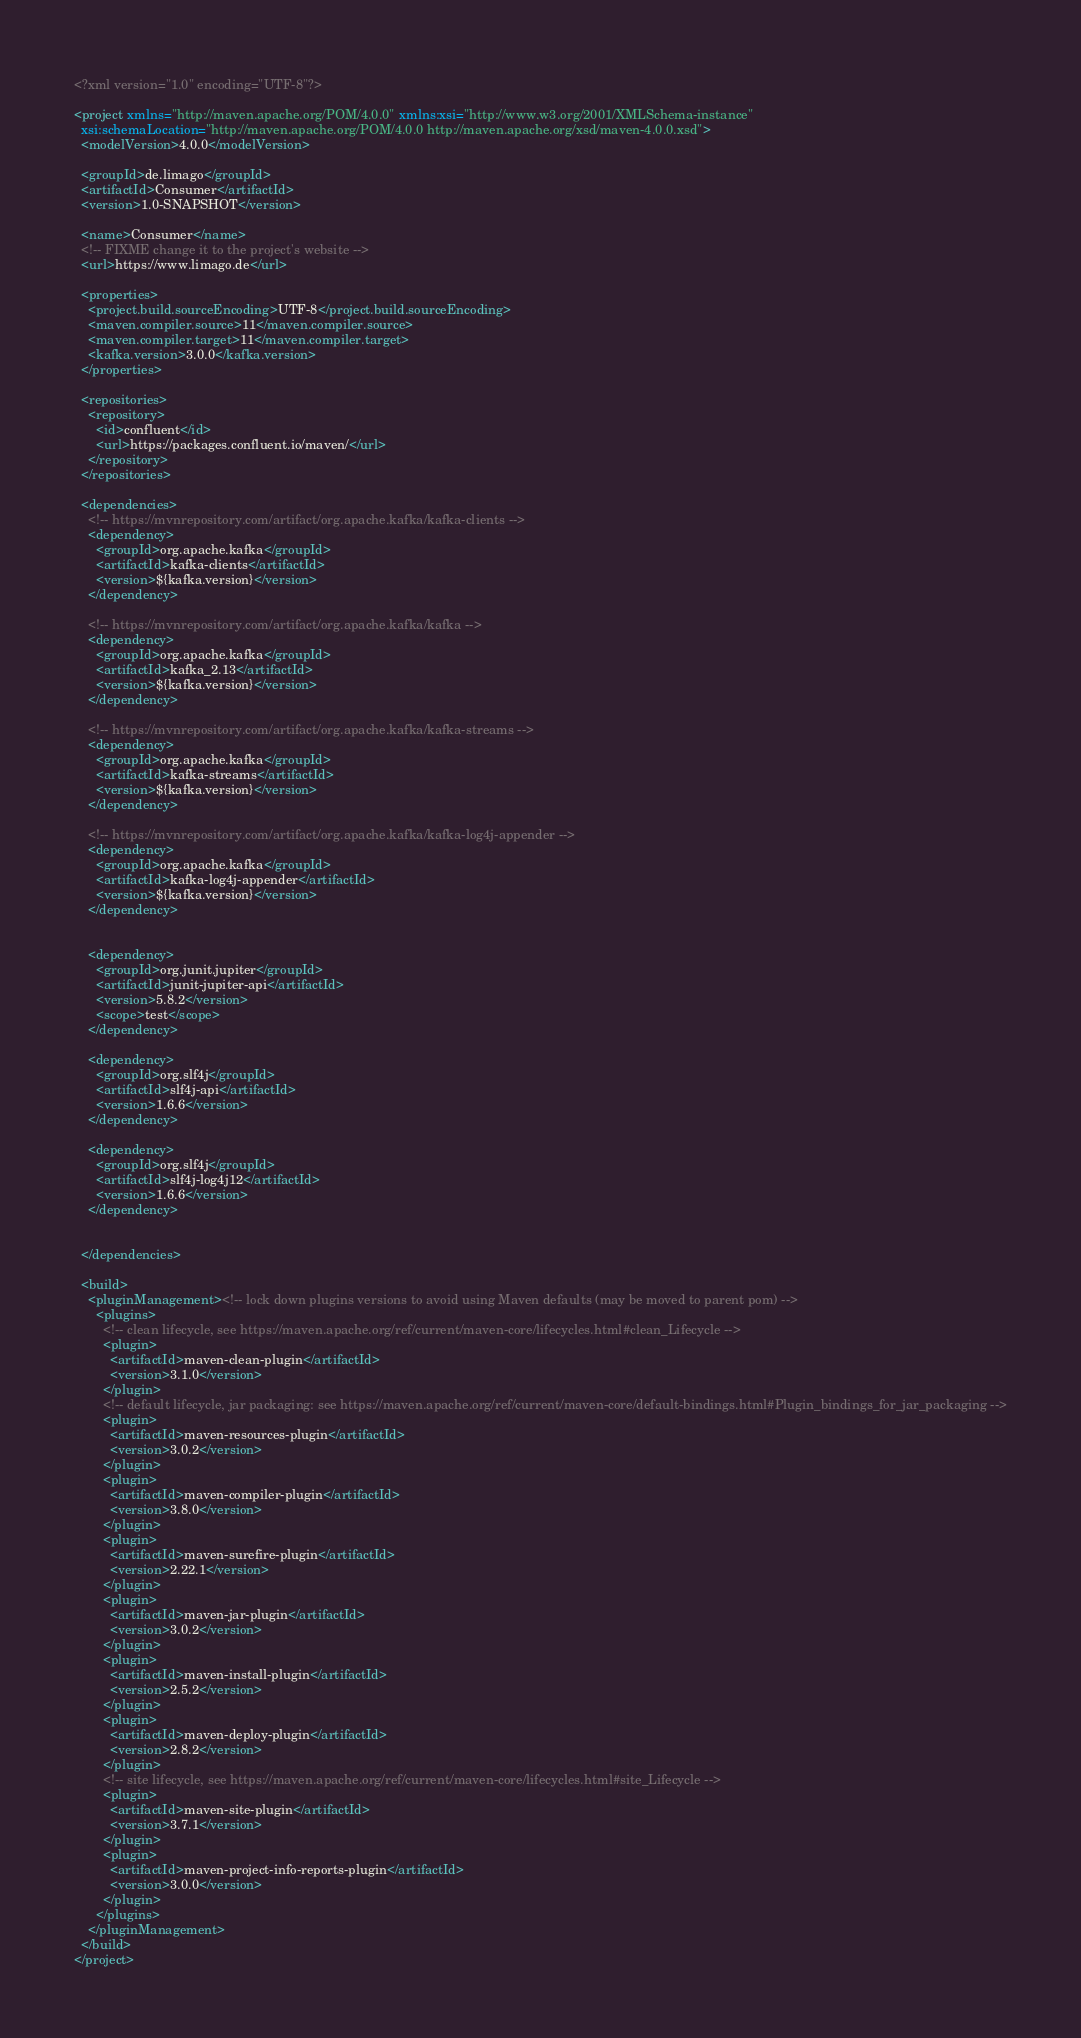<code> <loc_0><loc_0><loc_500><loc_500><_XML_><?xml version="1.0" encoding="UTF-8"?>

<project xmlns="http://maven.apache.org/POM/4.0.0" xmlns:xsi="http://www.w3.org/2001/XMLSchema-instance"
  xsi:schemaLocation="http://maven.apache.org/POM/4.0.0 http://maven.apache.org/xsd/maven-4.0.0.xsd">
  <modelVersion>4.0.0</modelVersion>

  <groupId>de.limago</groupId>
  <artifactId>Consumer</artifactId>
  <version>1.0-SNAPSHOT</version>

  <name>Consumer</name>
  <!-- FIXME change it to the project's website -->
  <url>https://www.limago.de</url>

  <properties>
    <project.build.sourceEncoding>UTF-8</project.build.sourceEncoding>
    <maven.compiler.source>11</maven.compiler.source>
    <maven.compiler.target>11</maven.compiler.target>
    <kafka.version>3.0.0</kafka.version>
  </properties>

  <repositories>
    <repository>
      <id>confluent</id>
      <url>https://packages.confluent.io/maven/</url>
    </repository>
  </repositories>

  <dependencies>
    <!-- https://mvnrepository.com/artifact/org.apache.kafka/kafka-clients -->
    <dependency>
      <groupId>org.apache.kafka</groupId>
      <artifactId>kafka-clients</artifactId>
      <version>${kafka.version}</version>
    </dependency>

    <!-- https://mvnrepository.com/artifact/org.apache.kafka/kafka -->
    <dependency>
      <groupId>org.apache.kafka</groupId>
      <artifactId>kafka_2.13</artifactId>
      <version>${kafka.version}</version>
    </dependency>

    <!-- https://mvnrepository.com/artifact/org.apache.kafka/kafka-streams -->
    <dependency>
      <groupId>org.apache.kafka</groupId>
      <artifactId>kafka-streams</artifactId>
      <version>${kafka.version}</version>
    </dependency>

    <!-- https://mvnrepository.com/artifact/org.apache.kafka/kafka-log4j-appender -->
    <dependency>
      <groupId>org.apache.kafka</groupId>
      <artifactId>kafka-log4j-appender</artifactId>
      <version>${kafka.version}</version>
    </dependency>


    <dependency>
      <groupId>org.junit.jupiter</groupId>
      <artifactId>junit-jupiter-api</artifactId>
      <version>5.8.2</version>
      <scope>test</scope>
    </dependency>

    <dependency>
      <groupId>org.slf4j</groupId>
      <artifactId>slf4j-api</artifactId>
      <version>1.6.6</version>
    </dependency>

    <dependency>
      <groupId>org.slf4j</groupId>
      <artifactId>slf4j-log4j12</artifactId>
      <version>1.6.6</version>
    </dependency>


  </dependencies>

  <build>
    <pluginManagement><!-- lock down plugins versions to avoid using Maven defaults (may be moved to parent pom) -->
      <plugins>
        <!-- clean lifecycle, see https://maven.apache.org/ref/current/maven-core/lifecycles.html#clean_Lifecycle -->
        <plugin>
          <artifactId>maven-clean-plugin</artifactId>
          <version>3.1.0</version>
        </plugin>
        <!-- default lifecycle, jar packaging: see https://maven.apache.org/ref/current/maven-core/default-bindings.html#Plugin_bindings_for_jar_packaging -->
        <plugin>
          <artifactId>maven-resources-plugin</artifactId>
          <version>3.0.2</version>
        </plugin>
        <plugin>
          <artifactId>maven-compiler-plugin</artifactId>
          <version>3.8.0</version>
        </plugin>
        <plugin>
          <artifactId>maven-surefire-plugin</artifactId>
          <version>2.22.1</version>
        </plugin>
        <plugin>
          <artifactId>maven-jar-plugin</artifactId>
          <version>3.0.2</version>
        </plugin>
        <plugin>
          <artifactId>maven-install-plugin</artifactId>
          <version>2.5.2</version>
        </plugin>
        <plugin>
          <artifactId>maven-deploy-plugin</artifactId>
          <version>2.8.2</version>
        </plugin>
        <!-- site lifecycle, see https://maven.apache.org/ref/current/maven-core/lifecycles.html#site_Lifecycle -->
        <plugin>
          <artifactId>maven-site-plugin</artifactId>
          <version>3.7.1</version>
        </plugin>
        <plugin>
          <artifactId>maven-project-info-reports-plugin</artifactId>
          <version>3.0.0</version>
        </plugin>
      </plugins>
    </pluginManagement>
  </build>
</project>
</code> 